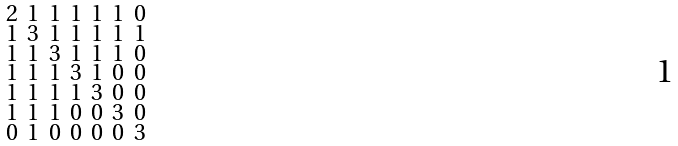Convert formula to latex. <formula><loc_0><loc_0><loc_500><loc_500>\begin{smallmatrix} 2 & 1 & 1 & 1 & 1 & 1 & 0 \\ 1 & 3 & 1 & 1 & 1 & 1 & 1 \\ 1 & 1 & 3 & 1 & 1 & 1 & 0 \\ 1 & 1 & 1 & 3 & 1 & 0 & 0 \\ 1 & 1 & 1 & 1 & 3 & 0 & 0 \\ 1 & 1 & 1 & 0 & 0 & 3 & 0 \\ 0 & 1 & 0 & 0 & 0 & 0 & 3 \end{smallmatrix}</formula> 